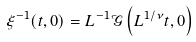Convert formula to latex. <formula><loc_0><loc_0><loc_500><loc_500>\xi ^ { - 1 } ( t , 0 ) = L ^ { - 1 } \mathcal { G } \left ( L ^ { 1 / \nu } t , 0 \right )</formula> 